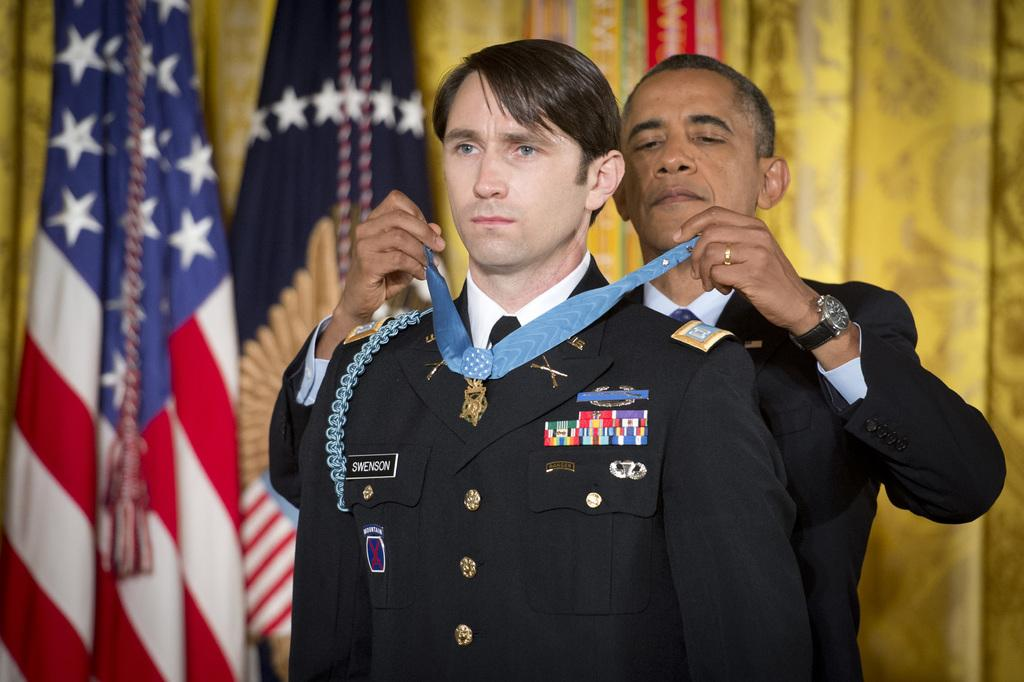<image>
Create a compact narrative representing the image presented. President Obama placing an award around service man named Swenson. 